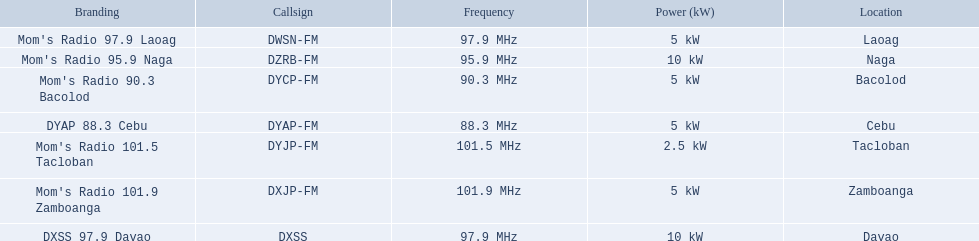Give me the full table as a dictionary. {'header': ['Branding', 'Callsign', 'Frequency', 'Power (kW)', 'Location'], 'rows': [["Mom's Radio 97.9 Laoag", 'DWSN-FM', '97.9\xa0MHz', '5\xa0kW', 'Laoag'], ["Mom's Radio 95.9 Naga", 'DZRB-FM', '95.9\xa0MHz', '10\xa0kW', 'Naga'], ["Mom's Radio 90.3 Bacolod", 'DYCP-FM', '90.3\xa0MHz', '5\xa0kW', 'Bacolod'], ['DYAP 88.3 Cebu', 'DYAP-FM', '88.3\xa0MHz', '5\xa0kW', 'Cebu'], ["Mom's Radio 101.5 Tacloban", 'DYJP-FM', '101.5\xa0MHz', '2.5\xa0kW', 'Tacloban'], ["Mom's Radio 101.9 Zamboanga", 'DXJP-FM', '101.9\xa0MHz', '5\xa0kW', 'Zamboanga'], ['DXSS 97.9 Davao', 'DXSS', '97.9\xa0MHz', '10\xa0kW', 'Davao']]} Which stations broadcast in dyap-fm? Mom's Radio 97.9 Laoag, Mom's Radio 95.9 Naga, Mom's Radio 90.3 Bacolod, DYAP 88.3 Cebu, Mom's Radio 101.5 Tacloban, Mom's Radio 101.9 Zamboanga, DXSS 97.9 Davao. Of those stations which broadcast in dyap-fm, which stations broadcast with 5kw of power or under? Mom's Radio 97.9 Laoag, Mom's Radio 90.3 Bacolod, DYAP 88.3 Cebu, Mom's Radio 101.5 Tacloban, Mom's Radio 101.9 Zamboanga. Of those stations that broadcast with 5kw of power or under, which broadcasts with the least power? Mom's Radio 101.5 Tacloban. What are the complete set of frequencies? 97.9 MHz, 95.9 MHz, 90.3 MHz, 88.3 MHz, 101.5 MHz, 101.9 MHz, 97.9 MHz. Which frequency has the lowest value? 88.3 MHz. Which label is associated with this frequency? DYAP 88.3 Cebu. What brand names feature a 5 kw power output? Mom's Radio 97.9 Laoag, Mom's Radio 90.3 Bacolod, DYAP 88.3 Cebu, Mom's Radio 101.9 Zamboanga. Which among them have a call-sign that begins with dy? Mom's Radio 90.3 Bacolod, DYAP 88.3 Cebu. Out of these, which brand operates on the lowest frequency? DYAP 88.3 Cebu. 